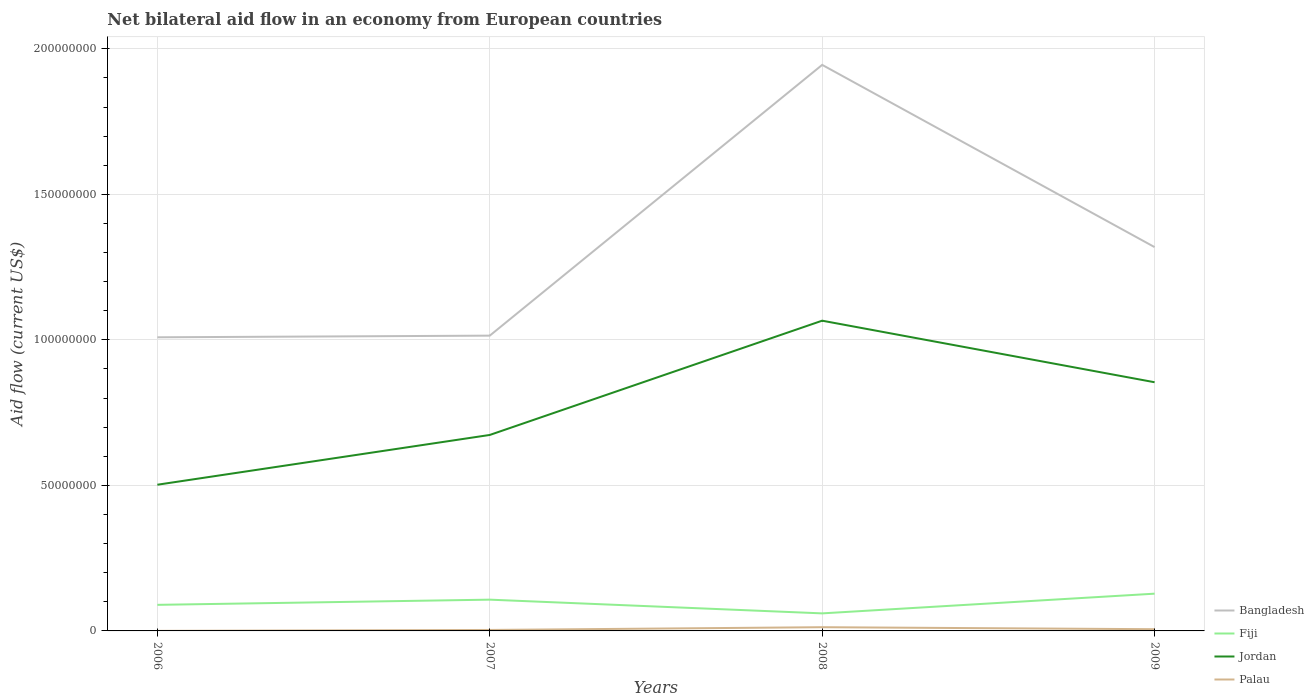Across all years, what is the maximum net bilateral aid flow in Jordan?
Offer a terse response. 5.02e+07. In which year was the net bilateral aid flow in Bangladesh maximum?
Provide a succinct answer. 2006. What is the total net bilateral aid flow in Jordan in the graph?
Give a very brief answer. -3.52e+07. What is the difference between the highest and the second highest net bilateral aid flow in Palau?
Ensure brevity in your answer.  1.26e+06. What is the difference between the highest and the lowest net bilateral aid flow in Bangladesh?
Provide a short and direct response. 1. How many lines are there?
Ensure brevity in your answer.  4. Are the values on the major ticks of Y-axis written in scientific E-notation?
Make the answer very short. No. What is the title of the graph?
Offer a very short reply. Net bilateral aid flow in an economy from European countries. What is the Aid flow (current US$) of Bangladesh in 2006?
Make the answer very short. 1.01e+08. What is the Aid flow (current US$) of Fiji in 2006?
Make the answer very short. 8.96e+06. What is the Aid flow (current US$) in Jordan in 2006?
Keep it short and to the point. 5.02e+07. What is the Aid flow (current US$) in Palau in 2006?
Keep it short and to the point. 2.00e+04. What is the Aid flow (current US$) of Bangladesh in 2007?
Offer a terse response. 1.01e+08. What is the Aid flow (current US$) in Fiji in 2007?
Your answer should be very brief. 1.07e+07. What is the Aid flow (current US$) in Jordan in 2007?
Offer a very short reply. 6.73e+07. What is the Aid flow (current US$) of Palau in 2007?
Your answer should be very brief. 3.30e+05. What is the Aid flow (current US$) in Bangladesh in 2008?
Keep it short and to the point. 1.94e+08. What is the Aid flow (current US$) in Fiji in 2008?
Your answer should be very brief. 6.03e+06. What is the Aid flow (current US$) of Jordan in 2008?
Your answer should be very brief. 1.07e+08. What is the Aid flow (current US$) of Palau in 2008?
Make the answer very short. 1.28e+06. What is the Aid flow (current US$) in Bangladesh in 2009?
Offer a very short reply. 1.32e+08. What is the Aid flow (current US$) of Fiji in 2009?
Make the answer very short. 1.28e+07. What is the Aid flow (current US$) of Jordan in 2009?
Your answer should be very brief. 8.54e+07. What is the Aid flow (current US$) of Palau in 2009?
Ensure brevity in your answer.  5.90e+05. Across all years, what is the maximum Aid flow (current US$) in Bangladesh?
Your answer should be very brief. 1.94e+08. Across all years, what is the maximum Aid flow (current US$) in Fiji?
Give a very brief answer. 1.28e+07. Across all years, what is the maximum Aid flow (current US$) of Jordan?
Offer a very short reply. 1.07e+08. Across all years, what is the maximum Aid flow (current US$) of Palau?
Offer a terse response. 1.28e+06. Across all years, what is the minimum Aid flow (current US$) of Bangladesh?
Give a very brief answer. 1.01e+08. Across all years, what is the minimum Aid flow (current US$) in Fiji?
Your response must be concise. 6.03e+06. Across all years, what is the minimum Aid flow (current US$) in Jordan?
Offer a very short reply. 5.02e+07. What is the total Aid flow (current US$) of Bangladesh in the graph?
Keep it short and to the point. 5.29e+08. What is the total Aid flow (current US$) in Fiji in the graph?
Your response must be concise. 3.85e+07. What is the total Aid flow (current US$) in Jordan in the graph?
Your answer should be compact. 3.10e+08. What is the total Aid flow (current US$) of Palau in the graph?
Your answer should be compact. 2.22e+06. What is the difference between the Aid flow (current US$) in Bangladesh in 2006 and that in 2007?
Offer a terse response. -5.70e+05. What is the difference between the Aid flow (current US$) of Fiji in 2006 and that in 2007?
Make the answer very short. -1.78e+06. What is the difference between the Aid flow (current US$) of Jordan in 2006 and that in 2007?
Your answer should be very brief. -1.71e+07. What is the difference between the Aid flow (current US$) of Palau in 2006 and that in 2007?
Provide a short and direct response. -3.10e+05. What is the difference between the Aid flow (current US$) in Bangladesh in 2006 and that in 2008?
Provide a succinct answer. -9.36e+07. What is the difference between the Aid flow (current US$) of Fiji in 2006 and that in 2008?
Your response must be concise. 2.93e+06. What is the difference between the Aid flow (current US$) of Jordan in 2006 and that in 2008?
Offer a very short reply. -5.64e+07. What is the difference between the Aid flow (current US$) in Palau in 2006 and that in 2008?
Your answer should be very brief. -1.26e+06. What is the difference between the Aid flow (current US$) of Bangladesh in 2006 and that in 2009?
Make the answer very short. -3.10e+07. What is the difference between the Aid flow (current US$) of Fiji in 2006 and that in 2009?
Provide a short and direct response. -3.84e+06. What is the difference between the Aid flow (current US$) in Jordan in 2006 and that in 2009?
Provide a short and direct response. -3.52e+07. What is the difference between the Aid flow (current US$) in Palau in 2006 and that in 2009?
Give a very brief answer. -5.70e+05. What is the difference between the Aid flow (current US$) in Bangladesh in 2007 and that in 2008?
Provide a succinct answer. -9.30e+07. What is the difference between the Aid flow (current US$) of Fiji in 2007 and that in 2008?
Provide a short and direct response. 4.71e+06. What is the difference between the Aid flow (current US$) in Jordan in 2007 and that in 2008?
Give a very brief answer. -3.93e+07. What is the difference between the Aid flow (current US$) in Palau in 2007 and that in 2008?
Your response must be concise. -9.50e+05. What is the difference between the Aid flow (current US$) of Bangladesh in 2007 and that in 2009?
Provide a succinct answer. -3.04e+07. What is the difference between the Aid flow (current US$) of Fiji in 2007 and that in 2009?
Offer a terse response. -2.06e+06. What is the difference between the Aid flow (current US$) of Jordan in 2007 and that in 2009?
Offer a very short reply. -1.81e+07. What is the difference between the Aid flow (current US$) in Bangladesh in 2008 and that in 2009?
Keep it short and to the point. 6.26e+07. What is the difference between the Aid flow (current US$) of Fiji in 2008 and that in 2009?
Make the answer very short. -6.77e+06. What is the difference between the Aid flow (current US$) in Jordan in 2008 and that in 2009?
Give a very brief answer. 2.12e+07. What is the difference between the Aid flow (current US$) in Palau in 2008 and that in 2009?
Your answer should be compact. 6.90e+05. What is the difference between the Aid flow (current US$) of Bangladesh in 2006 and the Aid flow (current US$) of Fiji in 2007?
Provide a short and direct response. 9.01e+07. What is the difference between the Aid flow (current US$) in Bangladesh in 2006 and the Aid flow (current US$) in Jordan in 2007?
Your answer should be compact. 3.36e+07. What is the difference between the Aid flow (current US$) in Bangladesh in 2006 and the Aid flow (current US$) in Palau in 2007?
Ensure brevity in your answer.  1.01e+08. What is the difference between the Aid flow (current US$) in Fiji in 2006 and the Aid flow (current US$) in Jordan in 2007?
Your answer should be compact. -5.84e+07. What is the difference between the Aid flow (current US$) of Fiji in 2006 and the Aid flow (current US$) of Palau in 2007?
Provide a succinct answer. 8.63e+06. What is the difference between the Aid flow (current US$) in Jordan in 2006 and the Aid flow (current US$) in Palau in 2007?
Ensure brevity in your answer.  4.99e+07. What is the difference between the Aid flow (current US$) of Bangladesh in 2006 and the Aid flow (current US$) of Fiji in 2008?
Provide a succinct answer. 9.48e+07. What is the difference between the Aid flow (current US$) in Bangladesh in 2006 and the Aid flow (current US$) in Jordan in 2008?
Provide a succinct answer. -5.71e+06. What is the difference between the Aid flow (current US$) of Bangladesh in 2006 and the Aid flow (current US$) of Palau in 2008?
Your answer should be very brief. 9.96e+07. What is the difference between the Aid flow (current US$) in Fiji in 2006 and the Aid flow (current US$) in Jordan in 2008?
Provide a succinct answer. -9.76e+07. What is the difference between the Aid flow (current US$) of Fiji in 2006 and the Aid flow (current US$) of Palau in 2008?
Ensure brevity in your answer.  7.68e+06. What is the difference between the Aid flow (current US$) in Jordan in 2006 and the Aid flow (current US$) in Palau in 2008?
Your answer should be compact. 4.90e+07. What is the difference between the Aid flow (current US$) in Bangladesh in 2006 and the Aid flow (current US$) in Fiji in 2009?
Keep it short and to the point. 8.81e+07. What is the difference between the Aid flow (current US$) in Bangladesh in 2006 and the Aid flow (current US$) in Jordan in 2009?
Offer a terse response. 1.54e+07. What is the difference between the Aid flow (current US$) of Bangladesh in 2006 and the Aid flow (current US$) of Palau in 2009?
Offer a very short reply. 1.00e+08. What is the difference between the Aid flow (current US$) in Fiji in 2006 and the Aid flow (current US$) in Jordan in 2009?
Your answer should be very brief. -7.65e+07. What is the difference between the Aid flow (current US$) of Fiji in 2006 and the Aid flow (current US$) of Palau in 2009?
Provide a succinct answer. 8.37e+06. What is the difference between the Aid flow (current US$) in Jordan in 2006 and the Aid flow (current US$) in Palau in 2009?
Offer a very short reply. 4.96e+07. What is the difference between the Aid flow (current US$) of Bangladesh in 2007 and the Aid flow (current US$) of Fiji in 2008?
Offer a very short reply. 9.54e+07. What is the difference between the Aid flow (current US$) of Bangladesh in 2007 and the Aid flow (current US$) of Jordan in 2008?
Your response must be concise. -5.14e+06. What is the difference between the Aid flow (current US$) of Bangladesh in 2007 and the Aid flow (current US$) of Palau in 2008?
Your answer should be very brief. 1.00e+08. What is the difference between the Aid flow (current US$) of Fiji in 2007 and the Aid flow (current US$) of Jordan in 2008?
Offer a terse response. -9.58e+07. What is the difference between the Aid flow (current US$) of Fiji in 2007 and the Aid flow (current US$) of Palau in 2008?
Make the answer very short. 9.46e+06. What is the difference between the Aid flow (current US$) of Jordan in 2007 and the Aid flow (current US$) of Palau in 2008?
Offer a terse response. 6.60e+07. What is the difference between the Aid flow (current US$) of Bangladesh in 2007 and the Aid flow (current US$) of Fiji in 2009?
Ensure brevity in your answer.  8.86e+07. What is the difference between the Aid flow (current US$) of Bangladesh in 2007 and the Aid flow (current US$) of Jordan in 2009?
Offer a terse response. 1.60e+07. What is the difference between the Aid flow (current US$) in Bangladesh in 2007 and the Aid flow (current US$) in Palau in 2009?
Provide a short and direct response. 1.01e+08. What is the difference between the Aid flow (current US$) of Fiji in 2007 and the Aid flow (current US$) of Jordan in 2009?
Make the answer very short. -7.47e+07. What is the difference between the Aid flow (current US$) of Fiji in 2007 and the Aid flow (current US$) of Palau in 2009?
Make the answer very short. 1.02e+07. What is the difference between the Aid flow (current US$) in Jordan in 2007 and the Aid flow (current US$) in Palau in 2009?
Give a very brief answer. 6.67e+07. What is the difference between the Aid flow (current US$) of Bangladesh in 2008 and the Aid flow (current US$) of Fiji in 2009?
Provide a short and direct response. 1.82e+08. What is the difference between the Aid flow (current US$) in Bangladesh in 2008 and the Aid flow (current US$) in Jordan in 2009?
Provide a short and direct response. 1.09e+08. What is the difference between the Aid flow (current US$) in Bangladesh in 2008 and the Aid flow (current US$) in Palau in 2009?
Make the answer very short. 1.94e+08. What is the difference between the Aid flow (current US$) in Fiji in 2008 and the Aid flow (current US$) in Jordan in 2009?
Your answer should be very brief. -7.94e+07. What is the difference between the Aid flow (current US$) of Fiji in 2008 and the Aid flow (current US$) of Palau in 2009?
Your answer should be very brief. 5.44e+06. What is the difference between the Aid flow (current US$) of Jordan in 2008 and the Aid flow (current US$) of Palau in 2009?
Your answer should be compact. 1.06e+08. What is the average Aid flow (current US$) of Bangladesh per year?
Offer a very short reply. 1.32e+08. What is the average Aid flow (current US$) of Fiji per year?
Keep it short and to the point. 9.63e+06. What is the average Aid flow (current US$) in Jordan per year?
Your answer should be compact. 7.74e+07. What is the average Aid flow (current US$) in Palau per year?
Offer a terse response. 5.55e+05. In the year 2006, what is the difference between the Aid flow (current US$) in Bangladesh and Aid flow (current US$) in Fiji?
Keep it short and to the point. 9.19e+07. In the year 2006, what is the difference between the Aid flow (current US$) of Bangladesh and Aid flow (current US$) of Jordan?
Your answer should be very brief. 5.06e+07. In the year 2006, what is the difference between the Aid flow (current US$) of Bangladesh and Aid flow (current US$) of Palau?
Provide a succinct answer. 1.01e+08. In the year 2006, what is the difference between the Aid flow (current US$) of Fiji and Aid flow (current US$) of Jordan?
Your answer should be very brief. -4.13e+07. In the year 2006, what is the difference between the Aid flow (current US$) of Fiji and Aid flow (current US$) of Palau?
Ensure brevity in your answer.  8.94e+06. In the year 2006, what is the difference between the Aid flow (current US$) in Jordan and Aid flow (current US$) in Palau?
Give a very brief answer. 5.02e+07. In the year 2007, what is the difference between the Aid flow (current US$) of Bangladesh and Aid flow (current US$) of Fiji?
Keep it short and to the point. 9.07e+07. In the year 2007, what is the difference between the Aid flow (current US$) of Bangladesh and Aid flow (current US$) of Jordan?
Provide a short and direct response. 3.41e+07. In the year 2007, what is the difference between the Aid flow (current US$) in Bangladesh and Aid flow (current US$) in Palau?
Offer a terse response. 1.01e+08. In the year 2007, what is the difference between the Aid flow (current US$) in Fiji and Aid flow (current US$) in Jordan?
Provide a succinct answer. -5.66e+07. In the year 2007, what is the difference between the Aid flow (current US$) in Fiji and Aid flow (current US$) in Palau?
Provide a succinct answer. 1.04e+07. In the year 2007, what is the difference between the Aid flow (current US$) in Jordan and Aid flow (current US$) in Palau?
Your answer should be compact. 6.70e+07. In the year 2008, what is the difference between the Aid flow (current US$) of Bangladesh and Aid flow (current US$) of Fiji?
Keep it short and to the point. 1.88e+08. In the year 2008, what is the difference between the Aid flow (current US$) in Bangladesh and Aid flow (current US$) in Jordan?
Your answer should be compact. 8.79e+07. In the year 2008, what is the difference between the Aid flow (current US$) of Bangladesh and Aid flow (current US$) of Palau?
Provide a short and direct response. 1.93e+08. In the year 2008, what is the difference between the Aid flow (current US$) of Fiji and Aid flow (current US$) of Jordan?
Your response must be concise. -1.01e+08. In the year 2008, what is the difference between the Aid flow (current US$) of Fiji and Aid flow (current US$) of Palau?
Offer a very short reply. 4.75e+06. In the year 2008, what is the difference between the Aid flow (current US$) in Jordan and Aid flow (current US$) in Palau?
Offer a very short reply. 1.05e+08. In the year 2009, what is the difference between the Aid flow (current US$) in Bangladesh and Aid flow (current US$) in Fiji?
Make the answer very short. 1.19e+08. In the year 2009, what is the difference between the Aid flow (current US$) in Bangladesh and Aid flow (current US$) in Jordan?
Offer a terse response. 4.64e+07. In the year 2009, what is the difference between the Aid flow (current US$) of Bangladesh and Aid flow (current US$) of Palau?
Provide a succinct answer. 1.31e+08. In the year 2009, what is the difference between the Aid flow (current US$) of Fiji and Aid flow (current US$) of Jordan?
Ensure brevity in your answer.  -7.26e+07. In the year 2009, what is the difference between the Aid flow (current US$) in Fiji and Aid flow (current US$) in Palau?
Provide a succinct answer. 1.22e+07. In the year 2009, what is the difference between the Aid flow (current US$) of Jordan and Aid flow (current US$) of Palau?
Ensure brevity in your answer.  8.48e+07. What is the ratio of the Aid flow (current US$) in Fiji in 2006 to that in 2007?
Your answer should be compact. 0.83. What is the ratio of the Aid flow (current US$) of Jordan in 2006 to that in 2007?
Provide a succinct answer. 0.75. What is the ratio of the Aid flow (current US$) in Palau in 2006 to that in 2007?
Provide a short and direct response. 0.06. What is the ratio of the Aid flow (current US$) in Bangladesh in 2006 to that in 2008?
Provide a short and direct response. 0.52. What is the ratio of the Aid flow (current US$) of Fiji in 2006 to that in 2008?
Keep it short and to the point. 1.49. What is the ratio of the Aid flow (current US$) in Jordan in 2006 to that in 2008?
Offer a very short reply. 0.47. What is the ratio of the Aid flow (current US$) of Palau in 2006 to that in 2008?
Your response must be concise. 0.02. What is the ratio of the Aid flow (current US$) in Bangladesh in 2006 to that in 2009?
Offer a terse response. 0.77. What is the ratio of the Aid flow (current US$) of Jordan in 2006 to that in 2009?
Keep it short and to the point. 0.59. What is the ratio of the Aid flow (current US$) of Palau in 2006 to that in 2009?
Ensure brevity in your answer.  0.03. What is the ratio of the Aid flow (current US$) of Bangladesh in 2007 to that in 2008?
Give a very brief answer. 0.52. What is the ratio of the Aid flow (current US$) in Fiji in 2007 to that in 2008?
Give a very brief answer. 1.78. What is the ratio of the Aid flow (current US$) in Jordan in 2007 to that in 2008?
Give a very brief answer. 0.63. What is the ratio of the Aid flow (current US$) in Palau in 2007 to that in 2008?
Keep it short and to the point. 0.26. What is the ratio of the Aid flow (current US$) of Bangladesh in 2007 to that in 2009?
Offer a very short reply. 0.77. What is the ratio of the Aid flow (current US$) in Fiji in 2007 to that in 2009?
Your answer should be very brief. 0.84. What is the ratio of the Aid flow (current US$) of Jordan in 2007 to that in 2009?
Provide a short and direct response. 0.79. What is the ratio of the Aid flow (current US$) in Palau in 2007 to that in 2009?
Provide a succinct answer. 0.56. What is the ratio of the Aid flow (current US$) in Bangladesh in 2008 to that in 2009?
Your answer should be very brief. 1.47. What is the ratio of the Aid flow (current US$) of Fiji in 2008 to that in 2009?
Ensure brevity in your answer.  0.47. What is the ratio of the Aid flow (current US$) in Jordan in 2008 to that in 2009?
Make the answer very short. 1.25. What is the ratio of the Aid flow (current US$) in Palau in 2008 to that in 2009?
Provide a short and direct response. 2.17. What is the difference between the highest and the second highest Aid flow (current US$) of Bangladesh?
Provide a short and direct response. 6.26e+07. What is the difference between the highest and the second highest Aid flow (current US$) in Fiji?
Your response must be concise. 2.06e+06. What is the difference between the highest and the second highest Aid flow (current US$) of Jordan?
Offer a very short reply. 2.12e+07. What is the difference between the highest and the second highest Aid flow (current US$) in Palau?
Keep it short and to the point. 6.90e+05. What is the difference between the highest and the lowest Aid flow (current US$) of Bangladesh?
Give a very brief answer. 9.36e+07. What is the difference between the highest and the lowest Aid flow (current US$) in Fiji?
Offer a very short reply. 6.77e+06. What is the difference between the highest and the lowest Aid flow (current US$) of Jordan?
Give a very brief answer. 5.64e+07. What is the difference between the highest and the lowest Aid flow (current US$) of Palau?
Make the answer very short. 1.26e+06. 